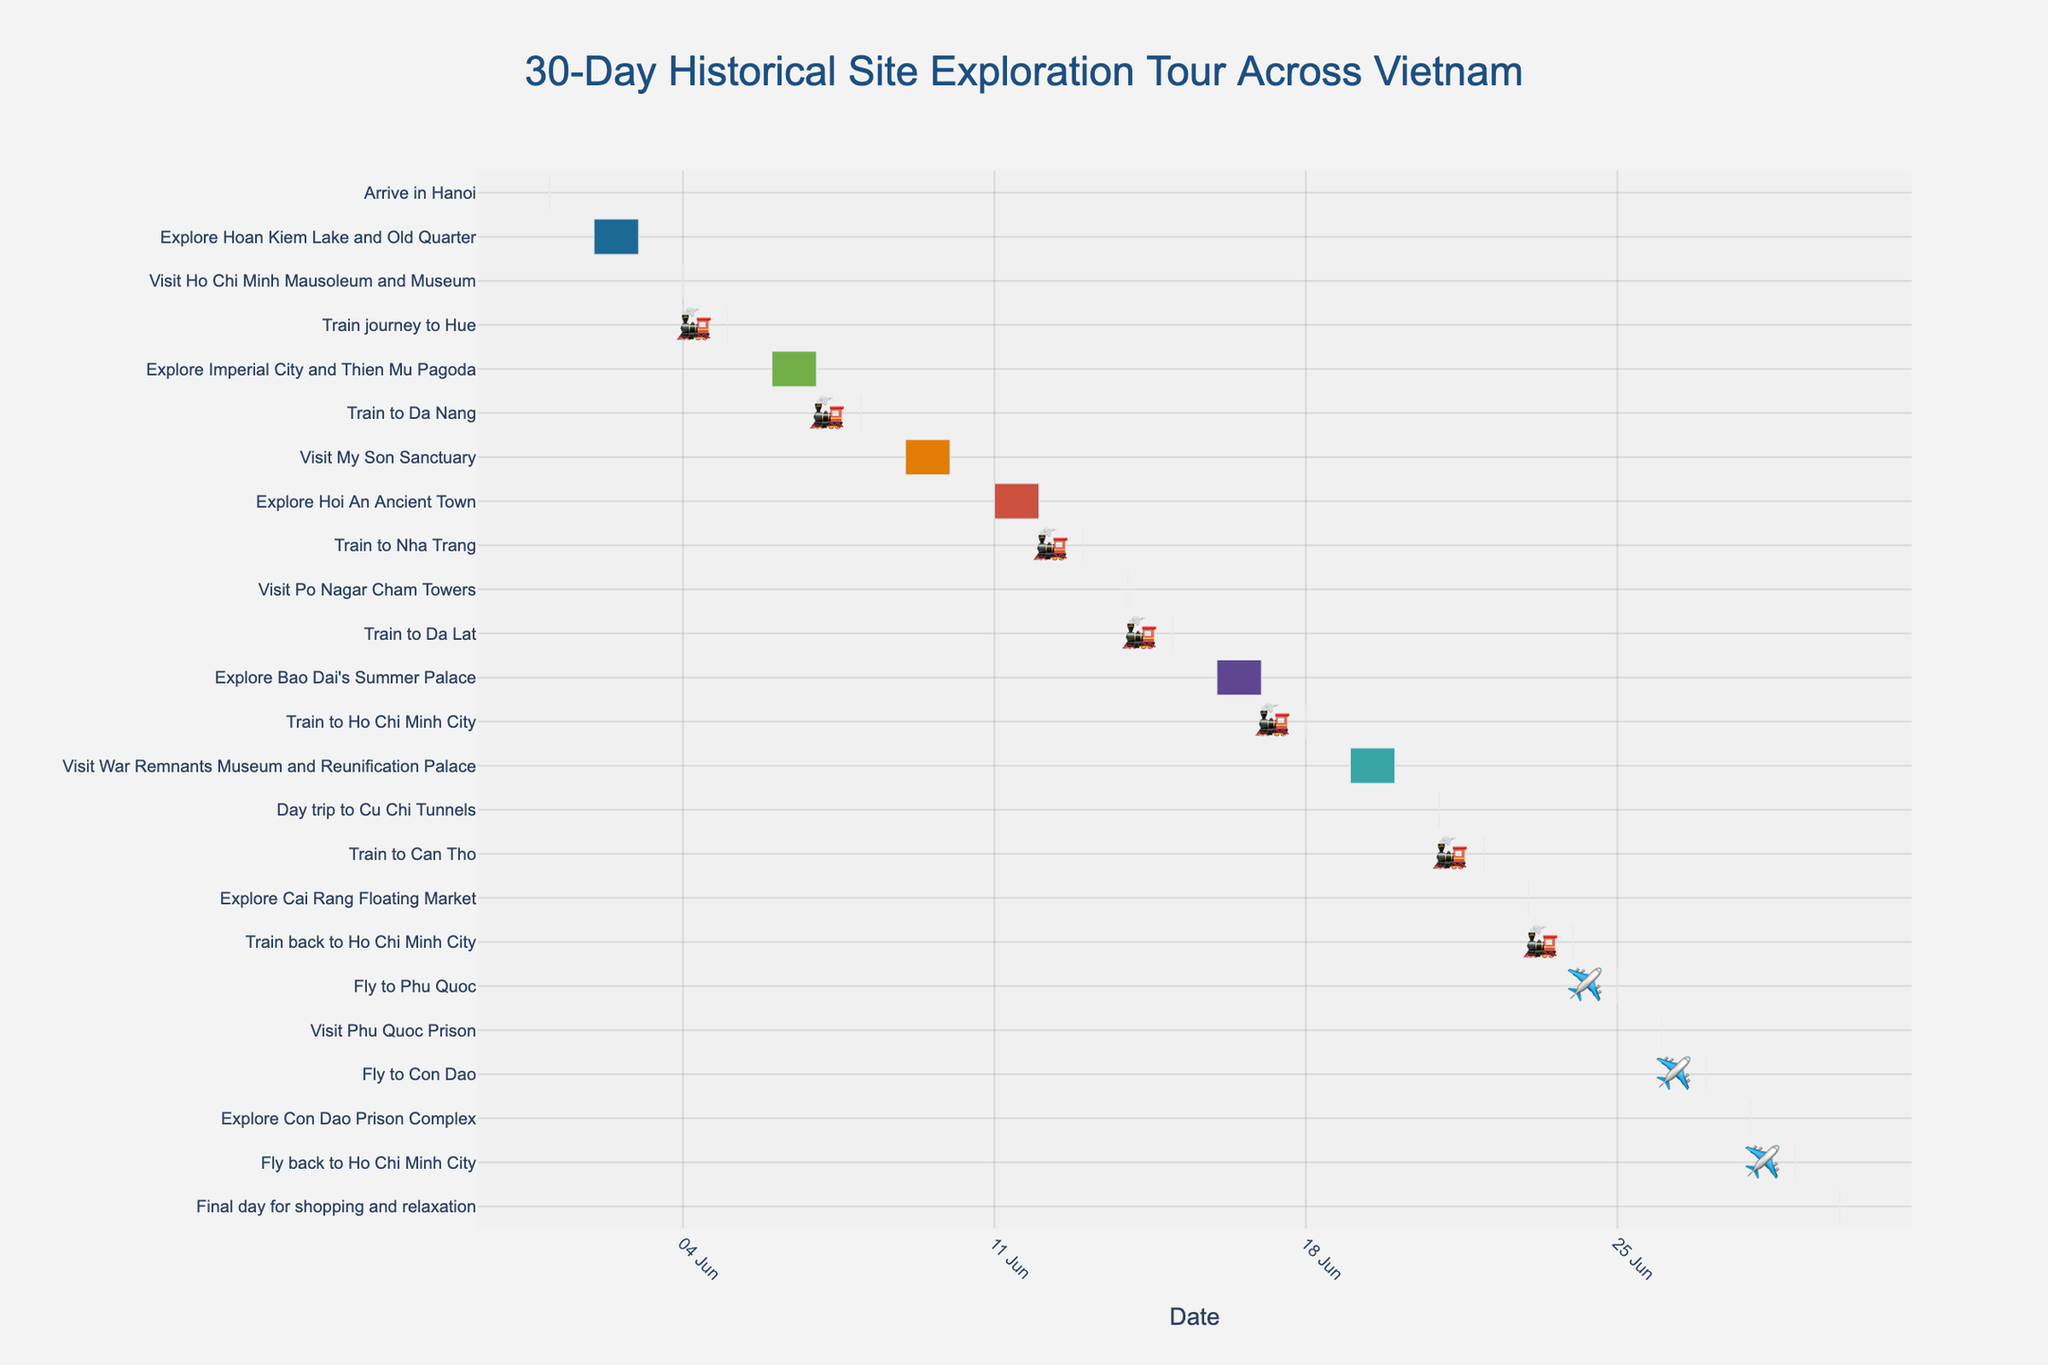What is the duration of the "Explore Hoan Kiem Lake and Old Quarter" activity? Look at the Gantt chart and locate the "Explore Hoan Kiem Lake and Old Quarter" task. Refer to the end of the task's bar to determine the start and end dates, then calculate the duration. The task starts on June 2 and ends on June 3, so the duration is 2 days.
Answer: 2 days Which activity has the shortest duration? Locate and compare the task bars to identify the one with the smallest span of days. "Arrive in Hanoi" and other travel tasks (like "Train journey to Hue" and "Fly to Phu Quoc") have a duration of 1 day.
Answer: Arrive in Hanoi How many train journeys are included in the schedule? Look for the train icons (🚂) in the Gantt chart. Count the number of train icons to get the total number of train journeys.
Answer: 7 What activities are scheduled on June 19 and June 20? Locate June 19 and June 20 on the Gantt chart and identify the task bars that span these dates. The "Visit War Remnants Museum and Reunification Palace" activity is scheduled for these dates.
Answer: Visit War Remnants Museum and Reunification Palace How long is the visit to the War Remnants Museum and Reunification Palace? Locate the task bar for "Visit War Remnants Museum and Reunification Palace" and check the start and end dates. Count the number of days between these two dates. The task starts on June 19 and ends on June 20, so the duration is 2 days.
Answer: 2 days What is the total number of days spent exploring Hoi An Ancient Town? Check the task bar labeled "Explore Hoi An Ancient Town" and note the start and end dates. The task starts on June 11 and ends on June 12, covering a period of 2 days.
Answer: 2 days How many days in total are spent in Ho Chi Minh City, considering all separate stays? Identify all periods where the activities are located in Ho Chi Minh City: June 18, June 19-21, June 24, June 29-30. Sum the days spent: June 18 (1 day), June 19-21 (3 days), June 24 (1 day), June 29-30 (2 days).
Answer: 7 days Which activities are immediately followed by a train journey? Identify activities that end just before a "Train to..." task starts. The activities are: "Visit Ho Chi Minh Mausoleum and Museum", "Explore Imperial City and Thien Mu Pagoda", "Explore Hoi An Ancient Town", "Visit Po Nagar Cham Towers", and "Explore Bao Dai's Summer Palace".
Answer: Visit Ho Chi Minh Mausoleum and Museum; Explore Imperial City and Thien Mu Pagoda; Explore Hoi An Ancient Town; Visit Po Nagar Cham Towers; Explore Bao Dai's Summer Palace On which dates is air travel scheduled? Look for the airplane icons (✈️) in the chart and note the corresponding dates. The air travel dates are June 25 (to Phu Quoc), June 27 (to Con Dao), and June 29 (back to Ho Chi Minh City).
Answer: June 25, June 27, June 29 